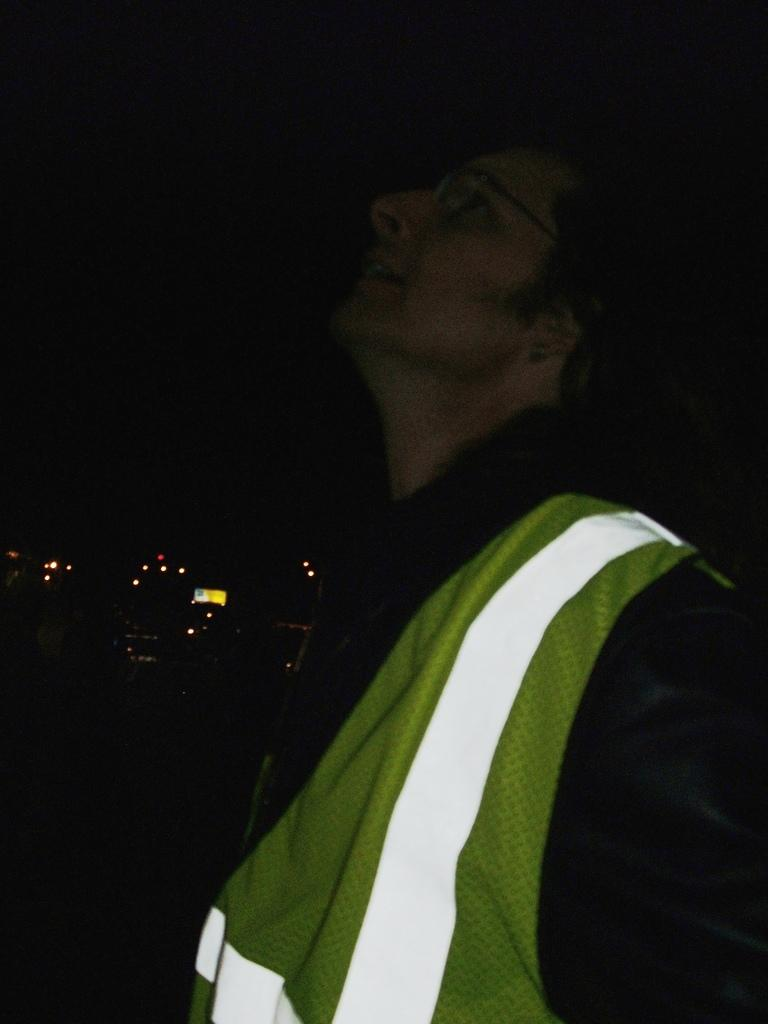Who is present in the image? There is a man in the image. What is the man wearing? The man is wearing a top with green, white, and black colors. Can you describe the background of the image? The background of the image is dark. What can be seen in addition to the man in the image? There are lights visible in the image. What type of horn can be seen on the man's head in the image? There is no horn present on the man's head in the image. How many balls is the man holding in the image? The man is not holding any balls in the image. 